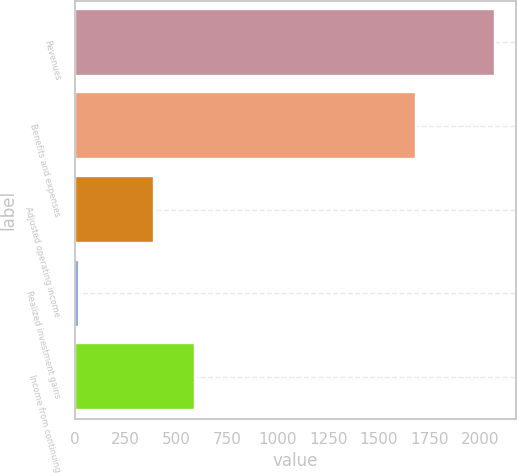Convert chart to OTSL. <chart><loc_0><loc_0><loc_500><loc_500><bar_chart><fcel>Revenues<fcel>Benefits and expenses<fcel>Adjusted operating income<fcel>Realized investment gains<fcel>Income from continuing<nl><fcel>2073<fcel>1683<fcel>390<fcel>23<fcel>595<nl></chart> 